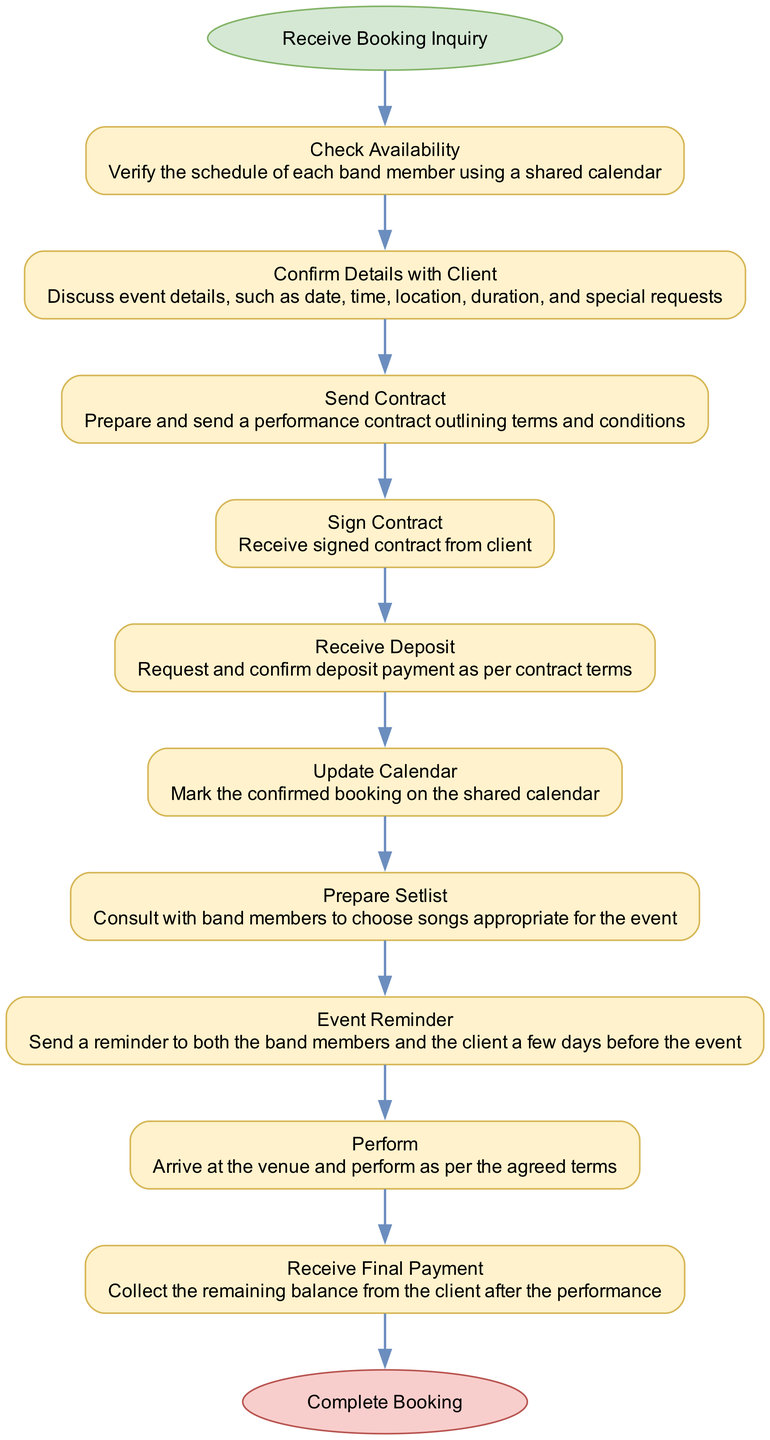What is the first action in the diagram? The first action in the diagram is indicated in the start node, which states "Receive Booking Inquiry". This is directly shown as the initial step leading into the flowchart.
Answer: Receive Booking Inquiry How many steps are in the booking process? The number of steps can be counted in the diagram; there are a total of 10 steps listed before reaching the end node. Counting each step from the flow yields this total.
Answer: 10 What action comes after "Check Availability"? Following the "Check Availability" action, which is the first step, the next action is "Confirm Details with Client" as seen in the sequential connections throughout the diagram.
Answer: Confirm Details with Client What is the last action before completing the booking? The last action before reaching the "Complete Booking" endpoint is "Receive Final Payment". This is determined as the final step leading into the end node in the flowchart.
Answer: Receive Final Payment Which action involves the client’s agreement? The action that involves the client's agreement is "Sign Contract". This is where the contract is signed by the client to formalize the booking terms, as indicated in the diagram's flow.
Answer: Sign Contract What happens if the deposit is not received? If the deposit is not received, according to standard operations, the calendar would not be updated, and the booking would likely remain uncertain. The diagram does not explicitly depict this, but typically, the steps would not continue without confirmation of the deposit.
Answer: Not mentioned in the diagram What action is taken after "Prepare Setlist"? The action taken after "Prepare Setlist" is "Event Reminder". This is the next step in the process, which follows the preparation of the setlist for the performance.
Answer: Event Reminder Which actions involve communication with the client? The actions that involve communication with the client are "Confirm Details with Client", "Send Contract", "Sign Contract", and "Event Reminder". Each of these steps requires interaction to convey information or receive acknowledgment.
Answer: Confirm Details with Client, Send Contract, Sign Contract, Event Reminder What document is sent following the confirmation of details? After confirming the details with the client, the document that is sent is the "Contract". This is the formalized document outlining the performance terms that must be provided to the client.
Answer: Contract 